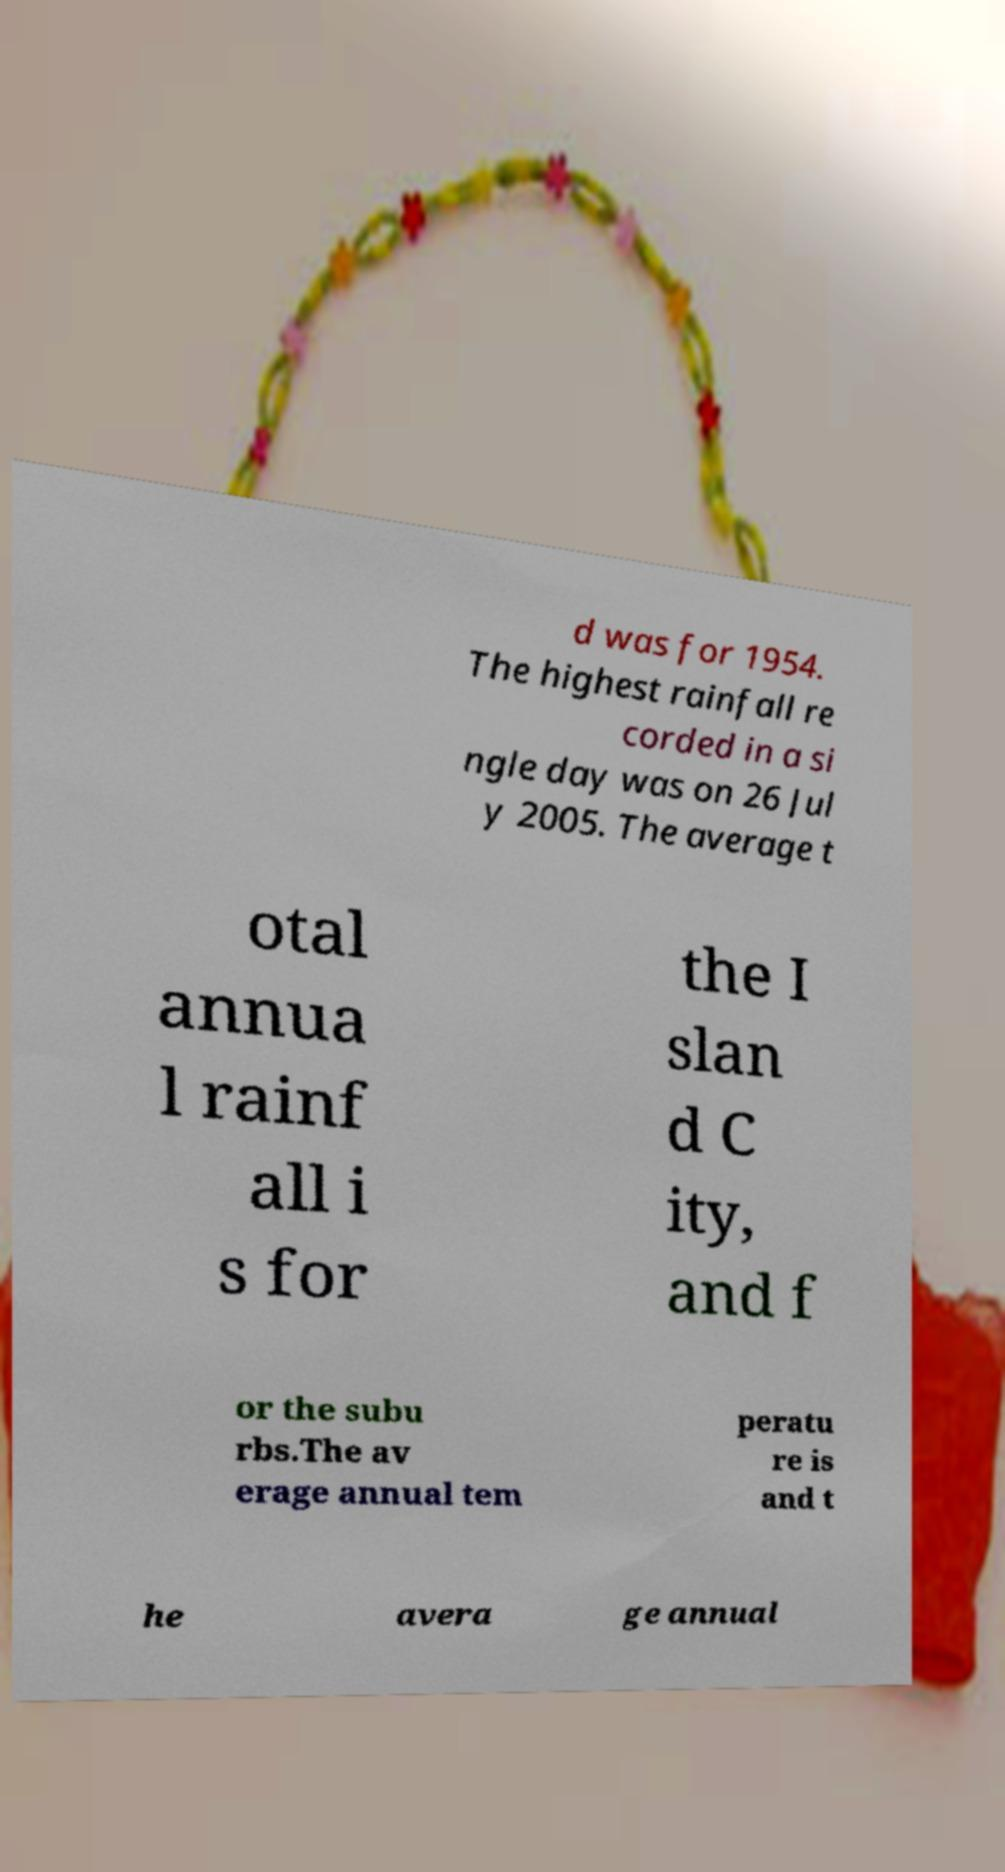Please identify and transcribe the text found in this image. d was for 1954. The highest rainfall re corded in a si ngle day was on 26 Jul y 2005. The average t otal annua l rainf all i s for the I slan d C ity, and f or the subu rbs.The av erage annual tem peratu re is and t he avera ge annual 